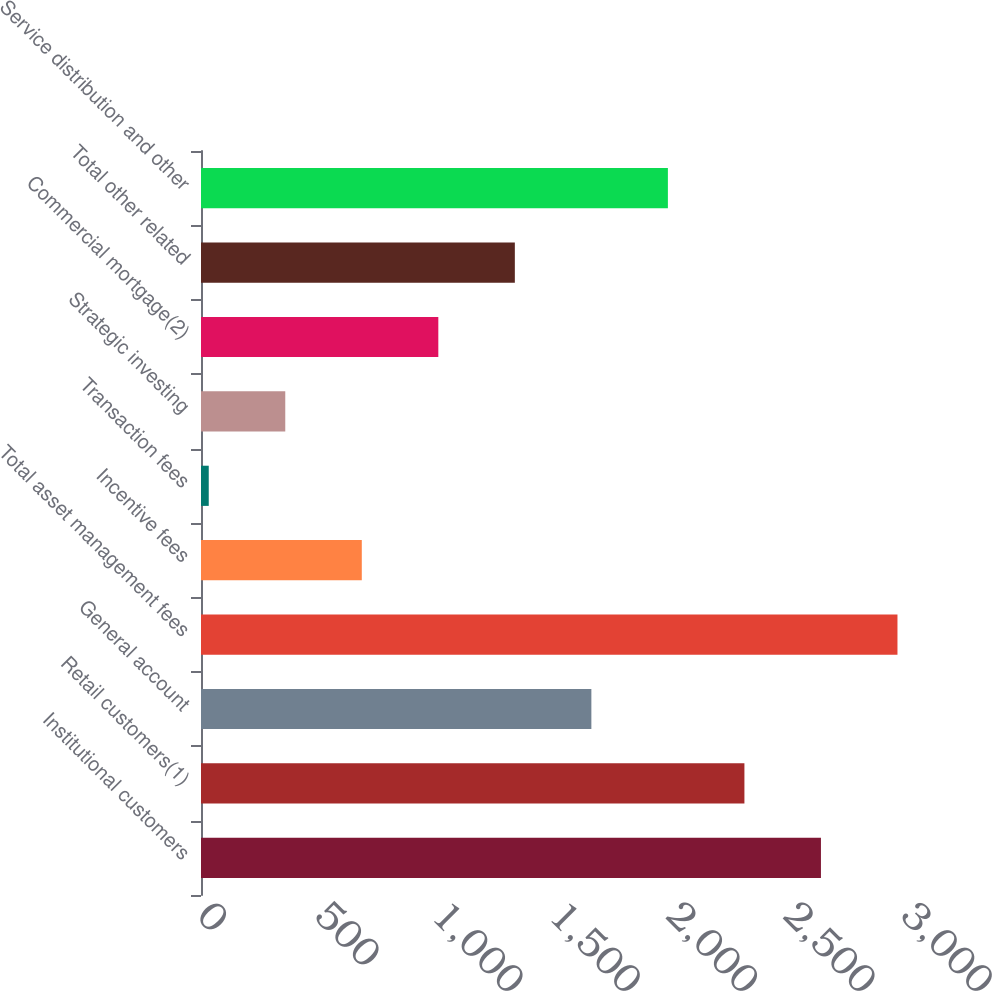Convert chart to OTSL. <chart><loc_0><loc_0><loc_500><loc_500><bar_chart><fcel>Institutional customers<fcel>Retail customers(1)<fcel>General account<fcel>Total asset management fees<fcel>Incentive fees<fcel>Transaction fees<fcel>Strategic investing<fcel>Commercial mortgage(2)<fcel>Total other related<fcel>Service distribution and other<nl><fcel>2641.8<fcel>2315.7<fcel>1663.5<fcel>2967.9<fcel>685.2<fcel>33<fcel>359.1<fcel>1011.3<fcel>1337.4<fcel>1989.6<nl></chart> 